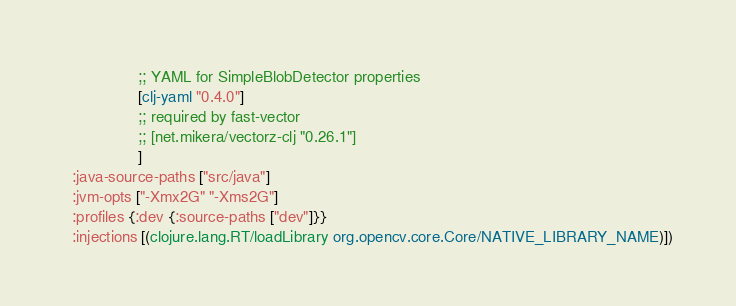<code> <loc_0><loc_0><loc_500><loc_500><_Clojure_>                 ;; YAML for SimpleBlobDetector properties
                 [clj-yaml "0.4.0"]
                 ;; required by fast-vector
                 ;; [net.mikera/vectorz-clj "0.26.1"]
                 ]
  :java-source-paths ["src/java"]
  :jvm-opts ["-Xmx2G" "-Xms2G"]
  :profiles {:dev {:source-paths ["dev"]}}
  :injections [(clojure.lang.RT/loadLibrary org.opencv.core.Core/NATIVE_LIBRARY_NAME)])
</code> 